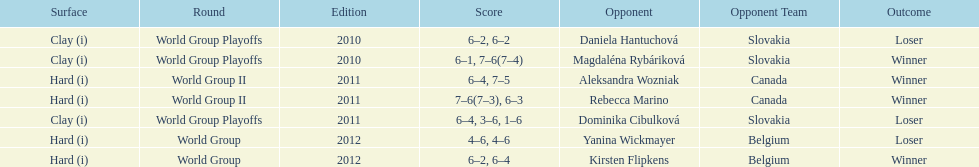Number of games in the match against dominika cibulkova? 3. 